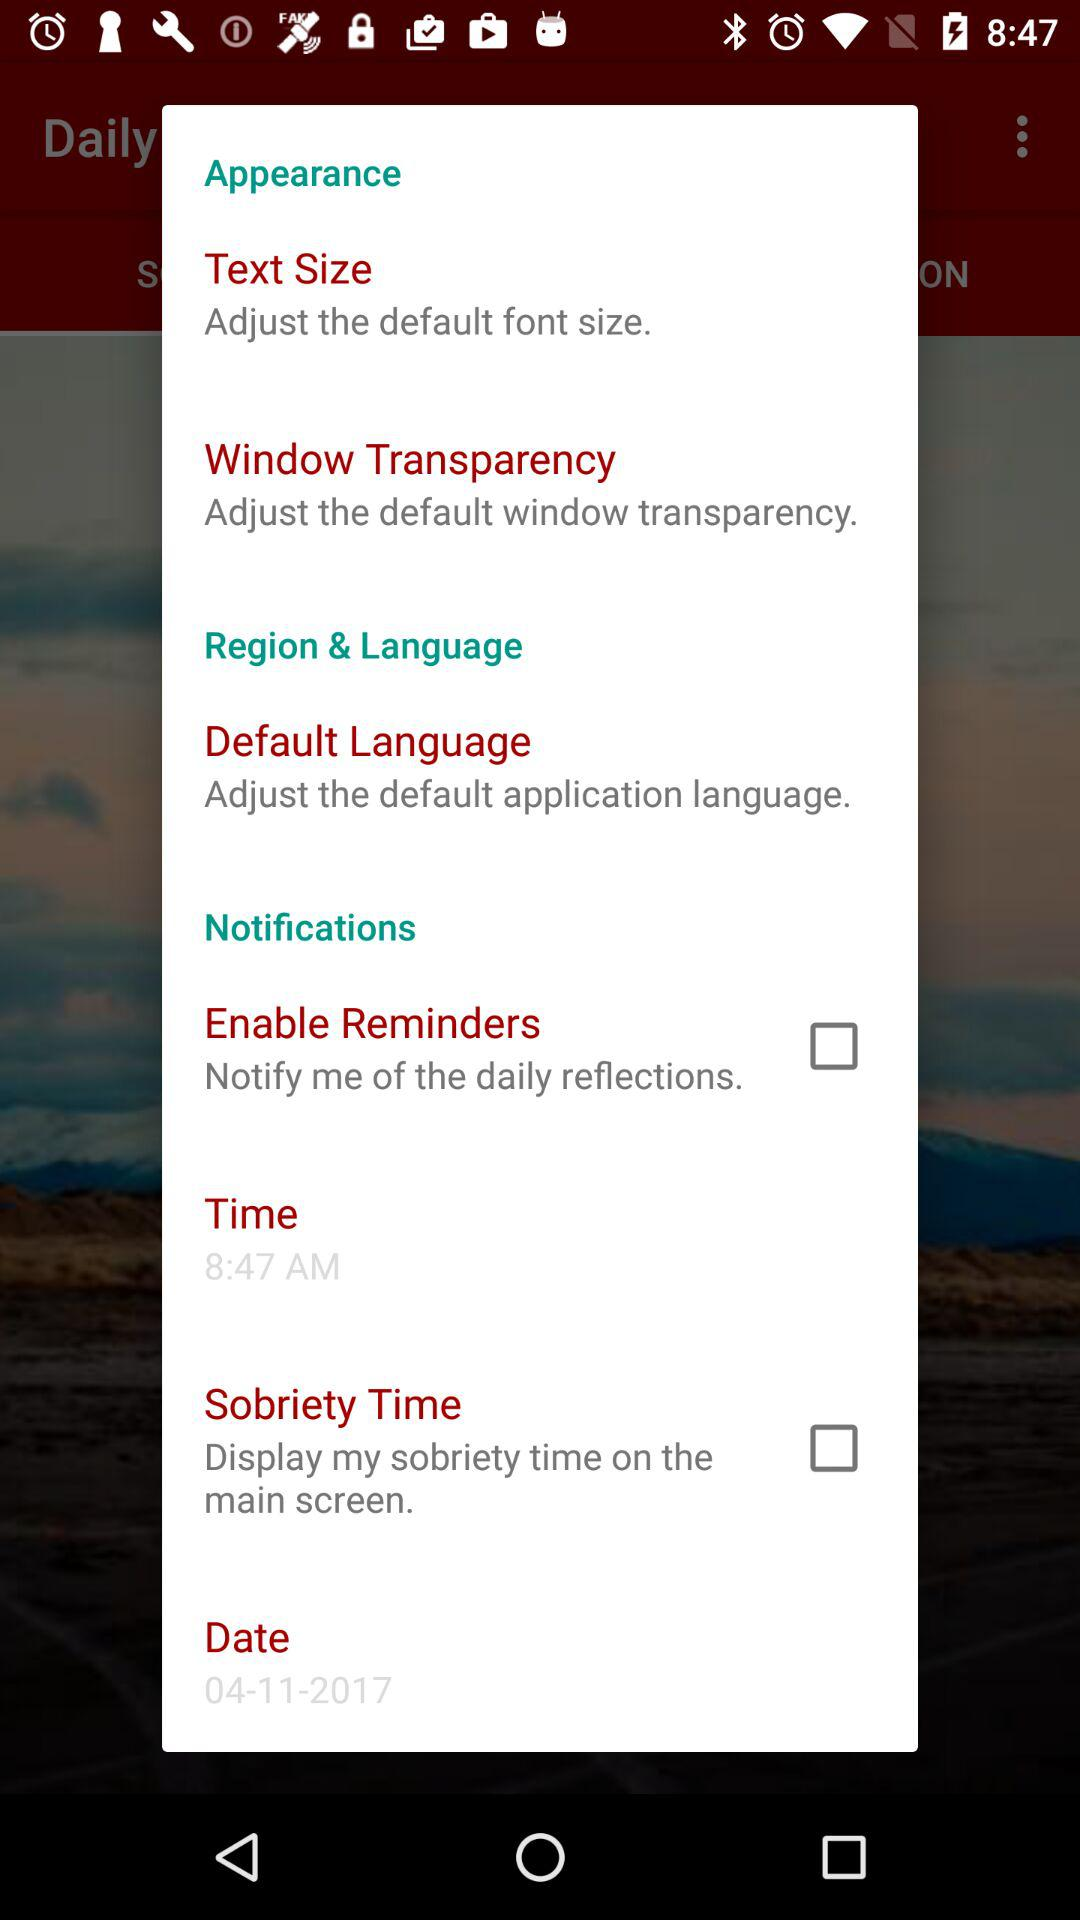What is the mentioned time? The mentioned time is 8:47 a.m. 